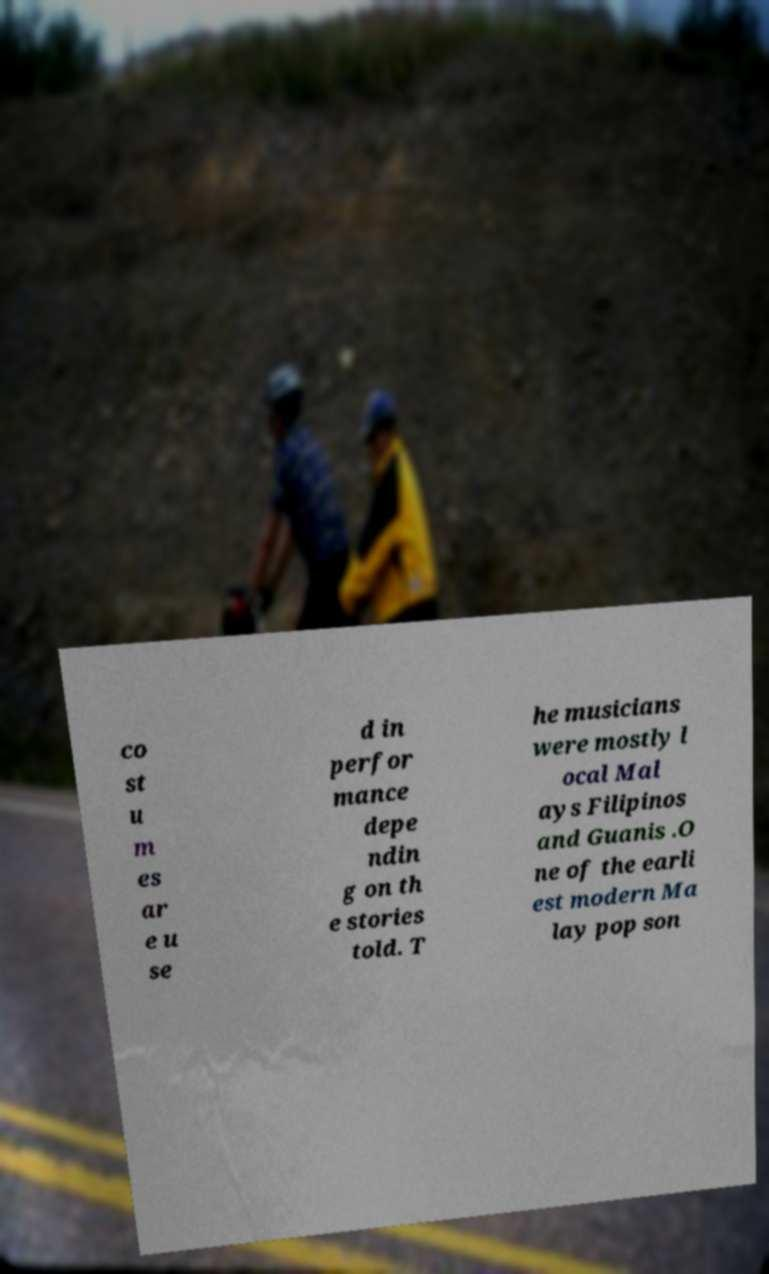Could you assist in decoding the text presented in this image and type it out clearly? co st u m es ar e u se d in perfor mance depe ndin g on th e stories told. T he musicians were mostly l ocal Mal ays Filipinos and Guanis .O ne of the earli est modern Ma lay pop son 